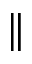Convert formula to latex. <formula><loc_0><loc_0><loc_500><loc_500>\|</formula> 